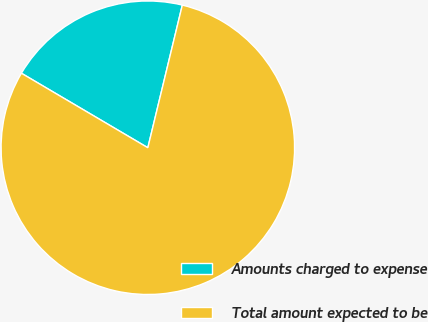Convert chart to OTSL. <chart><loc_0><loc_0><loc_500><loc_500><pie_chart><fcel>Amounts charged to expense<fcel>Total amount expected to be<nl><fcel>20.3%<fcel>79.7%<nl></chart> 